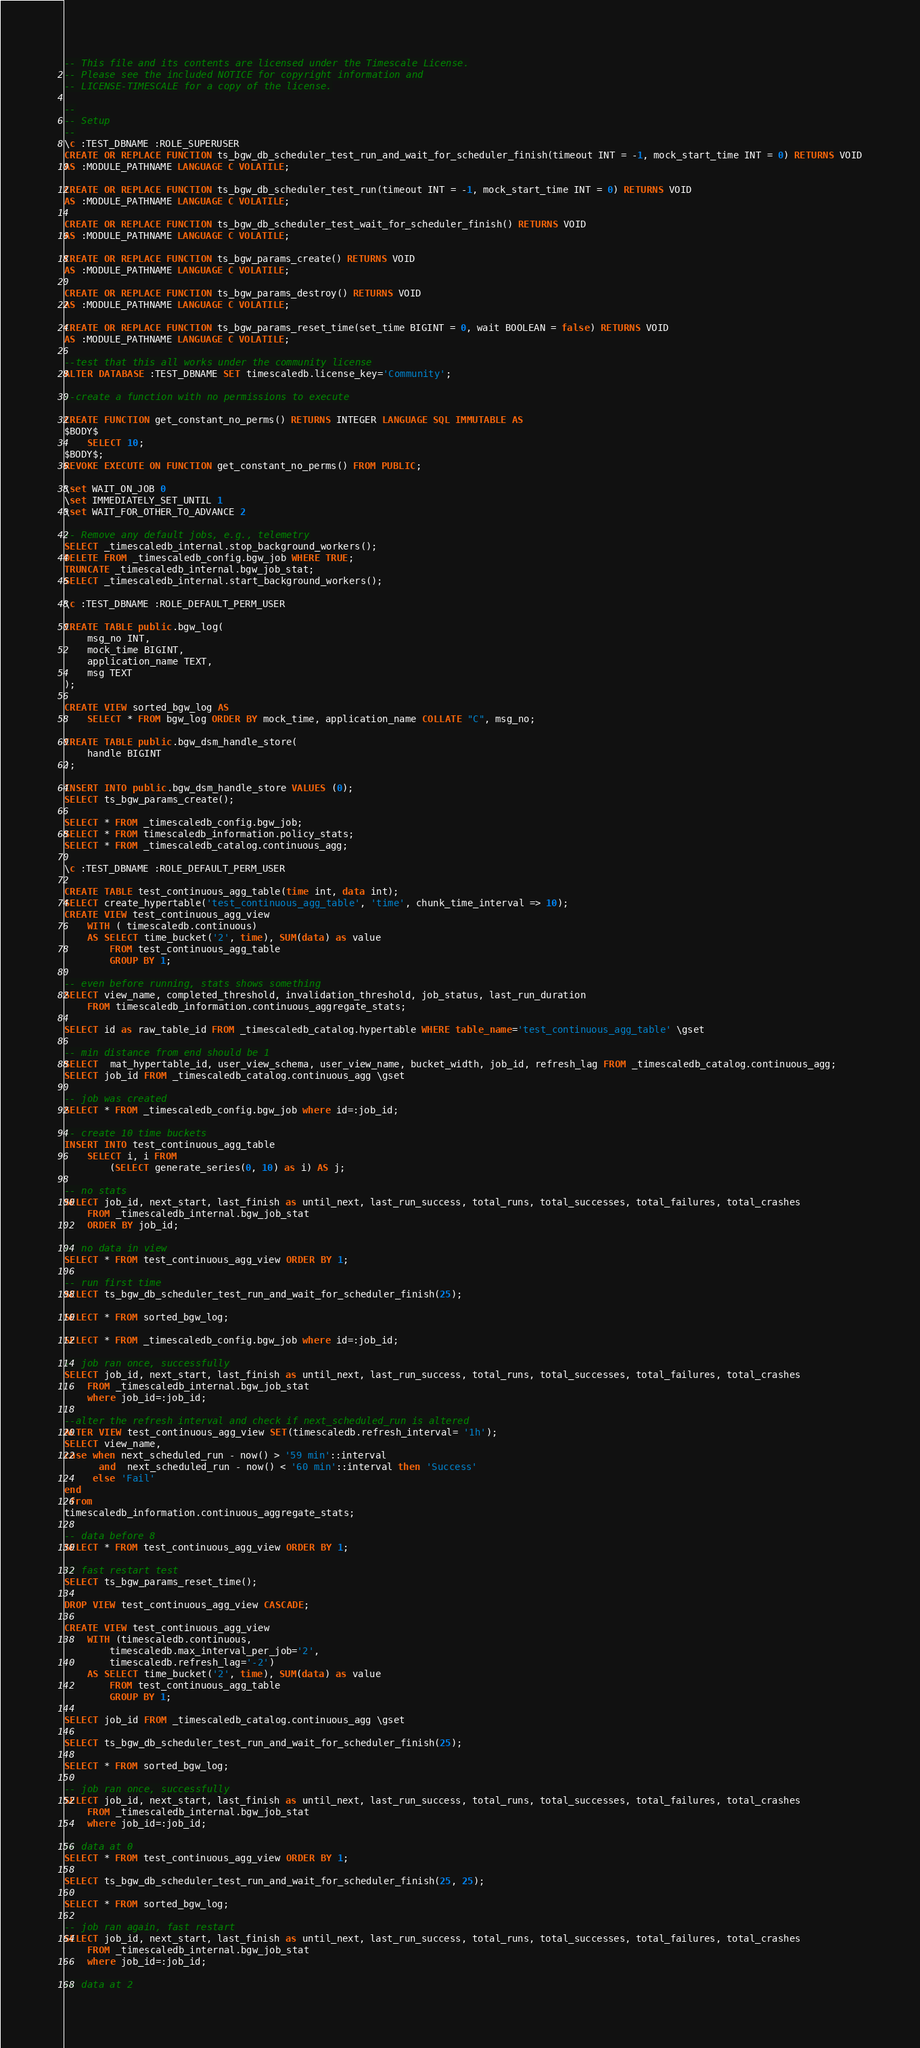Convert code to text. <code><loc_0><loc_0><loc_500><loc_500><_SQL_>-- This file and its contents are licensed under the Timescale License.
-- Please see the included NOTICE for copyright information and
-- LICENSE-TIMESCALE for a copy of the license.

--
-- Setup
--
\c :TEST_DBNAME :ROLE_SUPERUSER
CREATE OR REPLACE FUNCTION ts_bgw_db_scheduler_test_run_and_wait_for_scheduler_finish(timeout INT = -1, mock_start_time INT = 0) RETURNS VOID
AS :MODULE_PATHNAME LANGUAGE C VOLATILE;

CREATE OR REPLACE FUNCTION ts_bgw_db_scheduler_test_run(timeout INT = -1, mock_start_time INT = 0) RETURNS VOID
AS :MODULE_PATHNAME LANGUAGE C VOLATILE;

CREATE OR REPLACE FUNCTION ts_bgw_db_scheduler_test_wait_for_scheduler_finish() RETURNS VOID
AS :MODULE_PATHNAME LANGUAGE C VOLATILE;

CREATE OR REPLACE FUNCTION ts_bgw_params_create() RETURNS VOID
AS :MODULE_PATHNAME LANGUAGE C VOLATILE;

CREATE OR REPLACE FUNCTION ts_bgw_params_destroy() RETURNS VOID
AS :MODULE_PATHNAME LANGUAGE C VOLATILE;

CREATE OR REPLACE FUNCTION ts_bgw_params_reset_time(set_time BIGINT = 0, wait BOOLEAN = false) RETURNS VOID
AS :MODULE_PATHNAME LANGUAGE C VOLATILE;

--test that this all works under the community license
ALTER DATABASE :TEST_DBNAME SET timescaledb.license_key='Community';

--create a function with no permissions to execute

CREATE FUNCTION get_constant_no_perms() RETURNS INTEGER LANGUAGE SQL IMMUTABLE AS
$BODY$
    SELECT 10;
$BODY$;
REVOKE EXECUTE ON FUNCTION get_constant_no_perms() FROM PUBLIC;

\set WAIT_ON_JOB 0
\set IMMEDIATELY_SET_UNTIL 1
\set WAIT_FOR_OTHER_TO_ADVANCE 2

-- Remove any default jobs, e.g., telemetry
SELECT _timescaledb_internal.stop_background_workers();
DELETE FROM _timescaledb_config.bgw_job WHERE TRUE;
TRUNCATE _timescaledb_internal.bgw_job_stat;
SELECT _timescaledb_internal.start_background_workers();

\c :TEST_DBNAME :ROLE_DEFAULT_PERM_USER

CREATE TABLE public.bgw_log(
    msg_no INT,
    mock_time BIGINT,
    application_name TEXT,
    msg TEXT
);

CREATE VIEW sorted_bgw_log AS
    SELECT * FROM bgw_log ORDER BY mock_time, application_name COLLATE "C", msg_no;

CREATE TABLE public.bgw_dsm_handle_store(
    handle BIGINT
);

INSERT INTO public.bgw_dsm_handle_store VALUES (0);
SELECT ts_bgw_params_create();

SELECT * FROM _timescaledb_config.bgw_job;
SELECT * FROM timescaledb_information.policy_stats;
SELECT * FROM _timescaledb_catalog.continuous_agg;

\c :TEST_DBNAME :ROLE_DEFAULT_PERM_USER

CREATE TABLE test_continuous_agg_table(time int, data int);
SELECT create_hypertable('test_continuous_agg_table', 'time', chunk_time_interval => 10);
CREATE VIEW test_continuous_agg_view
    WITH ( timescaledb.continuous)
    AS SELECT time_bucket('2', time), SUM(data) as value
        FROM test_continuous_agg_table
        GROUP BY 1;

-- even before running, stats shows something
SELECT view_name, completed_threshold, invalidation_threshold, job_status, last_run_duration
    FROM timescaledb_information.continuous_aggregate_stats;

SELECT id as raw_table_id FROM _timescaledb_catalog.hypertable WHERE table_name='test_continuous_agg_table' \gset

-- min distance from end should be 1
SELECT  mat_hypertable_id, user_view_schema, user_view_name, bucket_width, job_id, refresh_lag FROM _timescaledb_catalog.continuous_agg;
SELECT job_id FROM _timescaledb_catalog.continuous_agg \gset

-- job was created
SELECT * FROM _timescaledb_config.bgw_job where id=:job_id;

-- create 10 time buckets
INSERT INTO test_continuous_agg_table
    SELECT i, i FROM
        (SELECT generate_series(0, 10) as i) AS j;

-- no stats
SELECT job_id, next_start, last_finish as until_next, last_run_success, total_runs, total_successes, total_failures, total_crashes
    FROM _timescaledb_internal.bgw_job_stat
    ORDER BY job_id;

-- no data in view
SELECT * FROM test_continuous_agg_view ORDER BY 1;

-- run first time
SELECT ts_bgw_db_scheduler_test_run_and_wait_for_scheduler_finish(25);

SELECT * FROM sorted_bgw_log;

SELECT * FROM _timescaledb_config.bgw_job where id=:job_id;

-- job ran once, successfully
SELECT job_id, next_start, last_finish as until_next, last_run_success, total_runs, total_successes, total_failures, total_crashes
    FROM _timescaledb_internal.bgw_job_stat
    where job_id=:job_id;

--alter the refresh interval and check if next_scheduled_run is altered
ALTER VIEW test_continuous_agg_view SET(timescaledb.refresh_interval= '1h');
SELECT view_name, 
case when next_scheduled_run - now() > '59 min'::interval 
      and  next_scheduled_run - now() < '60 min'::interval then 'Success'
     else 'Fail'
end 
 from 
timescaledb_information.continuous_aggregate_stats;

-- data before 8
SELECT * FROM test_continuous_agg_view ORDER BY 1;

-- fast restart test
SELECT ts_bgw_params_reset_time();

DROP VIEW test_continuous_agg_view CASCADE;

CREATE VIEW test_continuous_agg_view
    WITH (timescaledb.continuous,
        timescaledb.max_interval_per_job='2',
        timescaledb.refresh_lag='-2')
    AS SELECT time_bucket('2', time), SUM(data) as value
        FROM test_continuous_agg_table
        GROUP BY 1;

SELECT job_id FROM _timescaledb_catalog.continuous_agg \gset

SELECT ts_bgw_db_scheduler_test_run_and_wait_for_scheduler_finish(25);

SELECT * FROM sorted_bgw_log;

-- job ran once, successfully
SELECT job_id, next_start, last_finish as until_next, last_run_success, total_runs, total_successes, total_failures, total_crashes
    FROM _timescaledb_internal.bgw_job_stat
    where job_id=:job_id;

-- data at 0
SELECT * FROM test_continuous_agg_view ORDER BY 1;

SELECT ts_bgw_db_scheduler_test_run_and_wait_for_scheduler_finish(25, 25);

SELECT * FROM sorted_bgw_log;

-- job ran again, fast restart
SELECT job_id, next_start, last_finish as until_next, last_run_success, total_runs, total_successes, total_failures, total_crashes
    FROM _timescaledb_internal.bgw_job_stat
    where job_id=:job_id;

-- data at 2</code> 